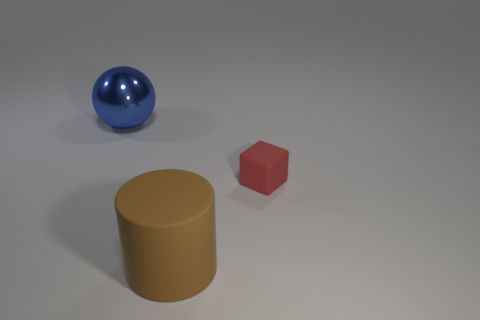Add 3 brown matte things. How many objects exist? 6 Subtract 1 spheres. How many spheres are left? 0 Subtract all brown balls. Subtract all gray cylinders. How many balls are left? 1 Add 3 small objects. How many small objects are left? 4 Add 1 shiny balls. How many shiny balls exist? 2 Subtract 0 green cylinders. How many objects are left? 3 Subtract all balls. How many objects are left? 2 Subtract all brown matte cylinders. Subtract all tiny blocks. How many objects are left? 1 